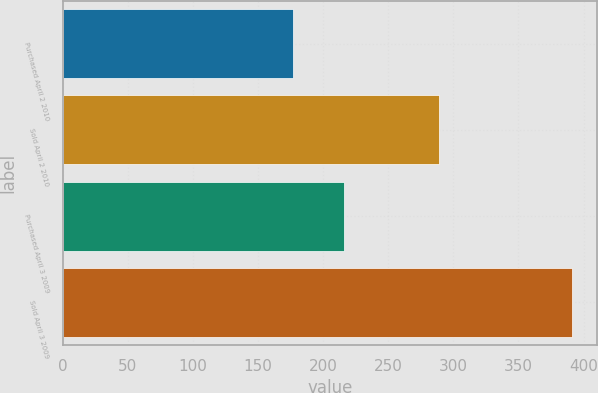Convert chart. <chart><loc_0><loc_0><loc_500><loc_500><bar_chart><fcel>Purchased April 2 2010<fcel>Sold April 2 2010<fcel>Purchased April 3 2009<fcel>Sold April 3 2009<nl><fcel>177<fcel>289<fcel>216<fcel>391<nl></chart> 